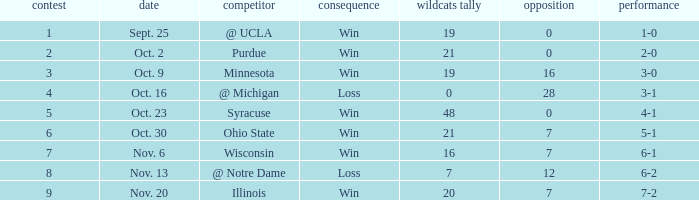How many wins or losses were there when the record was 3-0? 1.0. 